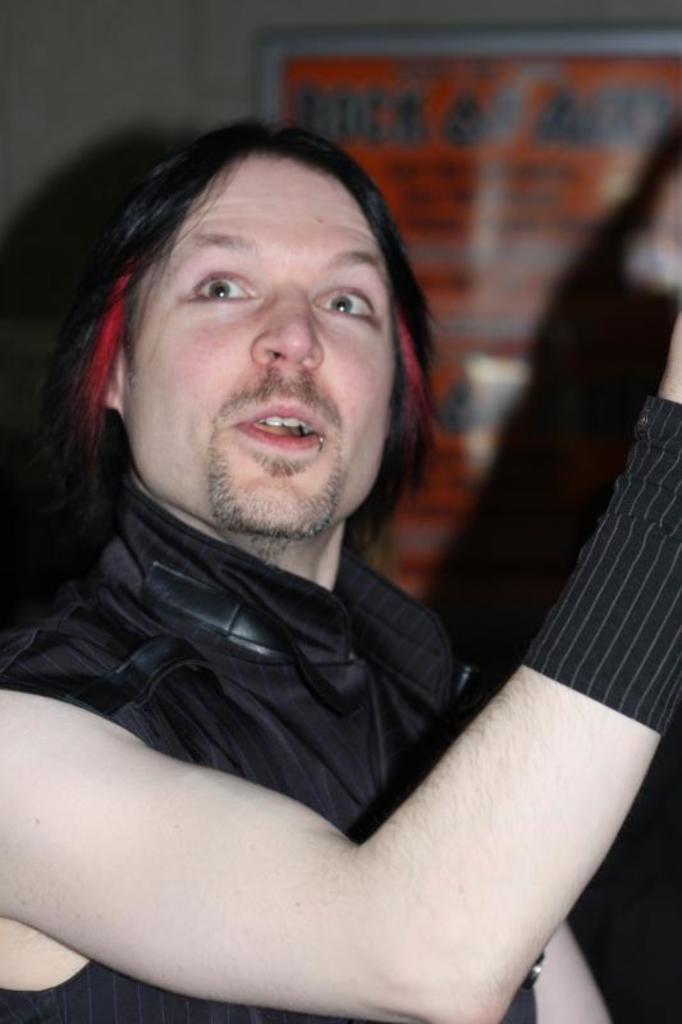Who is present in the image? There is a man in the image. What is the man wearing? The man is wearing a black jacket. What can be seen on the wall in the background of the image? There is a banner on the wall in the background of the image. What color is the crayon the man is using to rub on the rod in the image? There is no crayon, rubbing, or rod present in the image. 